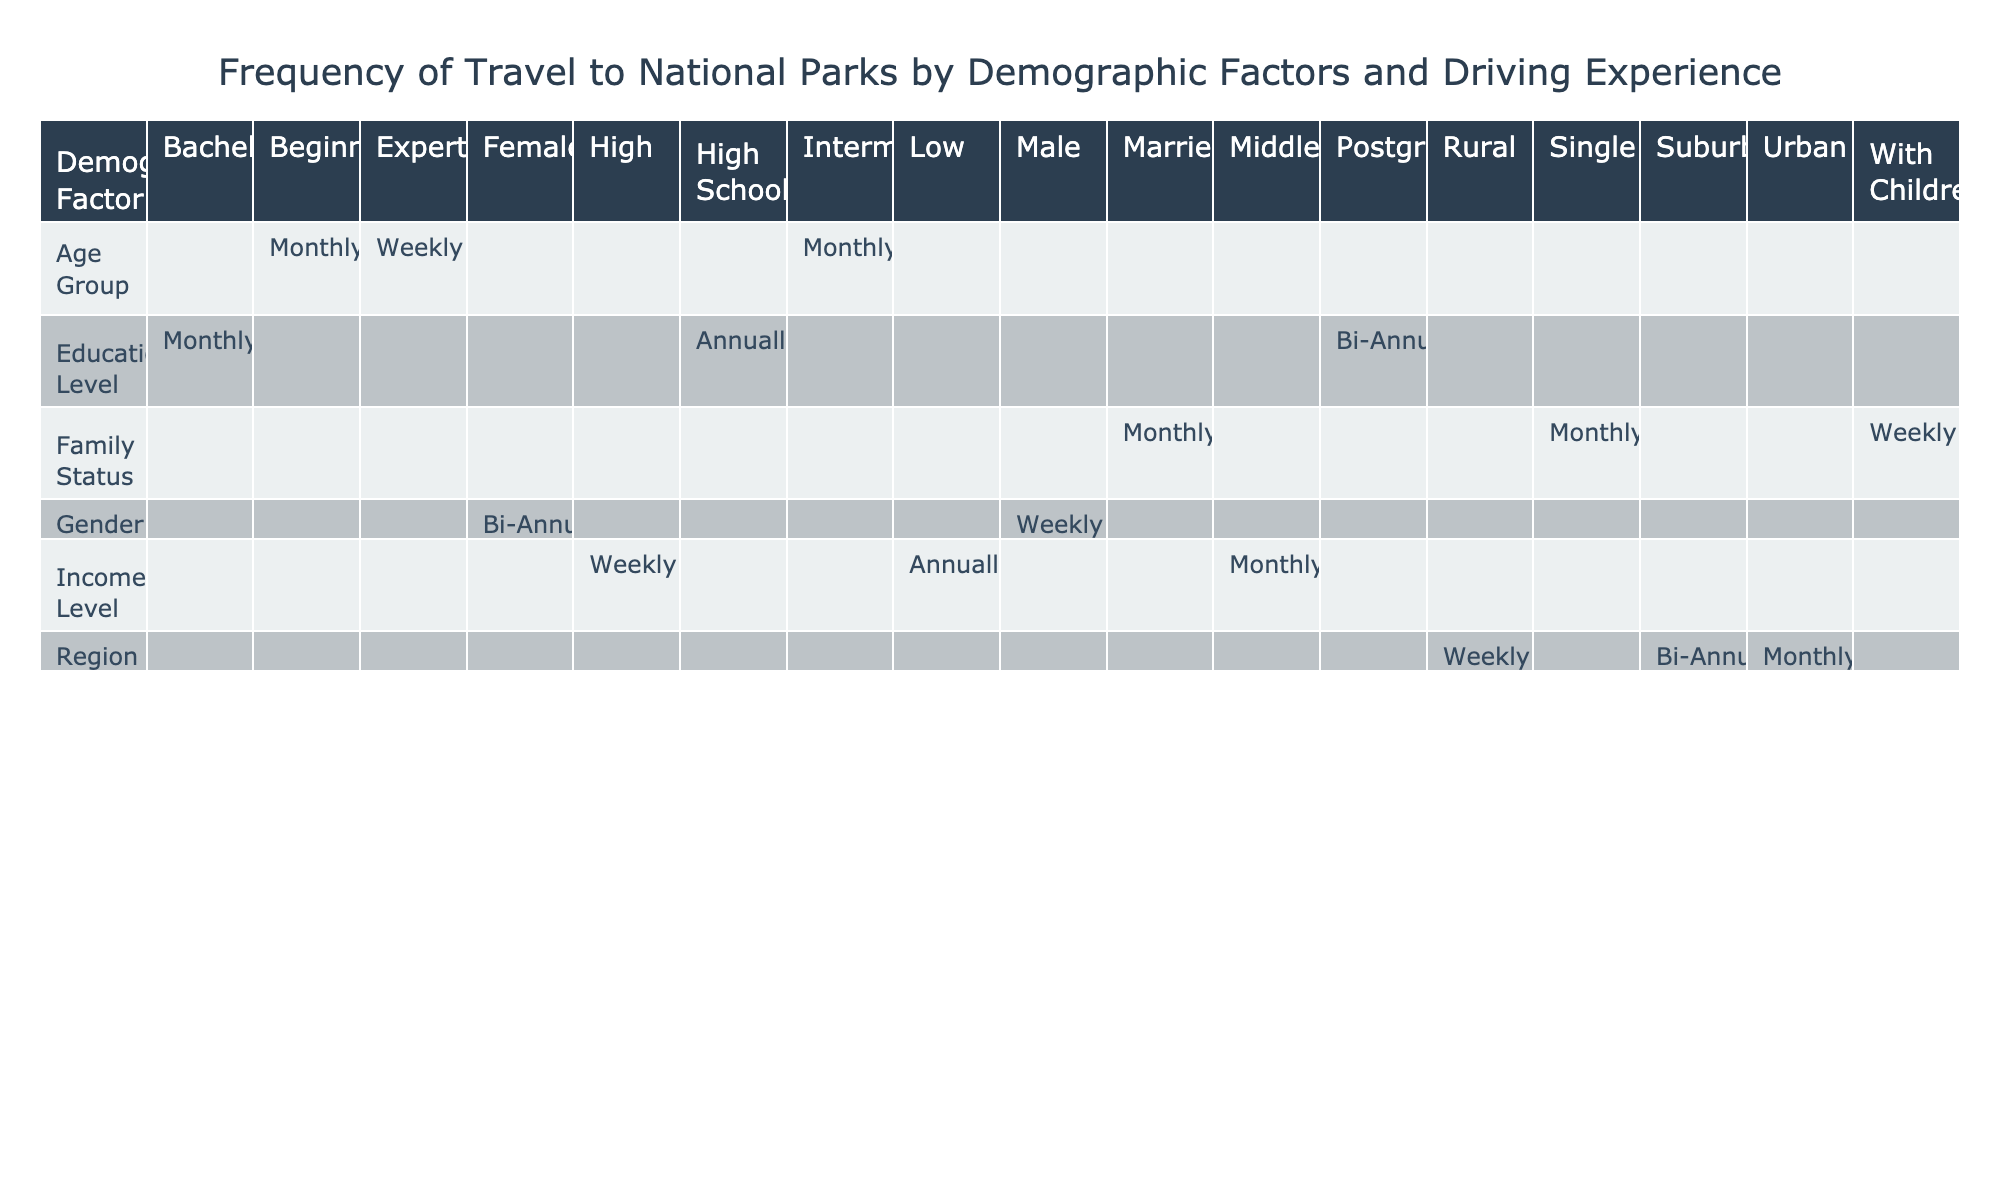What is the frequency of travel to national parks for males with beginner driving experience? According to the table, males with beginner driving experience travel to national parks monthly.
Answer: Monthly Which demographic group visits national parks more frequently, those with a high income or those with a low income? Looking at the table, individuals from the high-income group visit weekly, while those from the low-income group visit annually. Hence, the high-income group visits more frequently.
Answer: High income Is it true that both families with children and families without children visit parks at the same frequency? The table shows that families with children travel weekly, while family status is not specified for those without children. However, it indicates that single and married families travel monthly, thus families with children visit more frequently than the others.
Answer: No What is the frequency difference in park visits between urban and rural residents? Urban residents travel monthly while rural residents travel weekly. Calculating the difference in frequency, rural residents visit more often than urban residents.
Answer: Rural visit more frequently How many demographic factors listed have a frequency of travel to national parks that is monthly? The table indicates that four demographic factors (age group, income level, family status, and education level) list 'monthly' as their frequency of travel.
Answer: Four Do couples with children visit national parks more frequently than those who are single? Families with children visit weekly while single individuals visit monthly; since weekly visits are more frequent than monthly, couples with children visit more often than singles.
Answer: Yes Which driving experience level has the most frequent visits and what is that frequency? Examining the table, experts visit weekly, which is the most frequent visit compared to others. Therefore, experts have the highest frequency.
Answer: Weekly What is the average frequency of travel to national parks for all age groups? Each age group’s frequency is categorized as follows: beginner (monthly), intermediate (monthly), and expert (weekly). Converting frequencies to a numerical scale (monthly = 1, weekly = 4): average = (1 + 1 + 4)/3 = 2. So the average frequency is bi-monthly.
Answer: Bi-monthly How do postgraduate education level travelers' frequency compare to those with a high income? According to the table, postgraduate travelers visit bi-annually, while high-income travelers visit weekly. Weekly visits indicate a higher frequency compared to bi-annual visits, showing high-income travelers go to parks more often than postgraduate-level travelers.
Answer: High-income travelers visit more often 